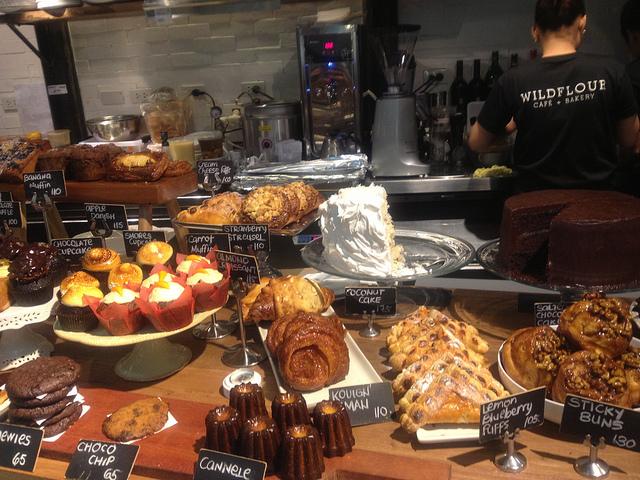Is there anything chocolate in this photo?
Write a very short answer. Yes. Is this a cafe?
Give a very brief answer. Yes. Is this a store with diet food?
Give a very brief answer. No. 